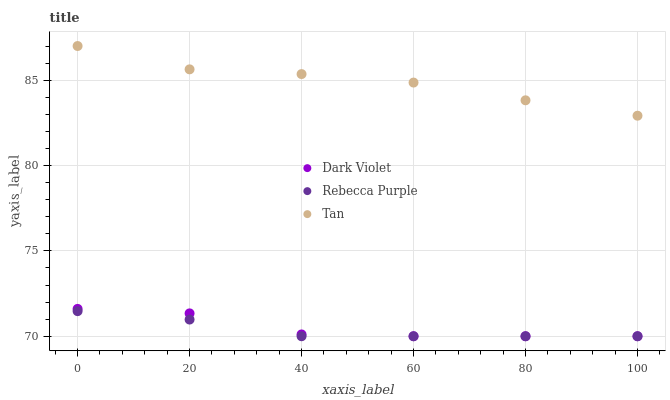Does Rebecca Purple have the minimum area under the curve?
Answer yes or no. Yes. Does Tan have the maximum area under the curve?
Answer yes or no. Yes. Does Dark Violet have the minimum area under the curve?
Answer yes or no. No. Does Dark Violet have the maximum area under the curve?
Answer yes or no. No. Is Rebecca Purple the smoothest?
Answer yes or no. Yes. Is Dark Violet the roughest?
Answer yes or no. Yes. Is Dark Violet the smoothest?
Answer yes or no. No. Is Rebecca Purple the roughest?
Answer yes or no. No. Does Rebecca Purple have the lowest value?
Answer yes or no. Yes. Does Tan have the highest value?
Answer yes or no. Yes. Does Dark Violet have the highest value?
Answer yes or no. No. Is Rebecca Purple less than Tan?
Answer yes or no. Yes. Is Tan greater than Rebecca Purple?
Answer yes or no. Yes. Does Dark Violet intersect Rebecca Purple?
Answer yes or no. Yes. Is Dark Violet less than Rebecca Purple?
Answer yes or no. No. Is Dark Violet greater than Rebecca Purple?
Answer yes or no. No. Does Rebecca Purple intersect Tan?
Answer yes or no. No. 